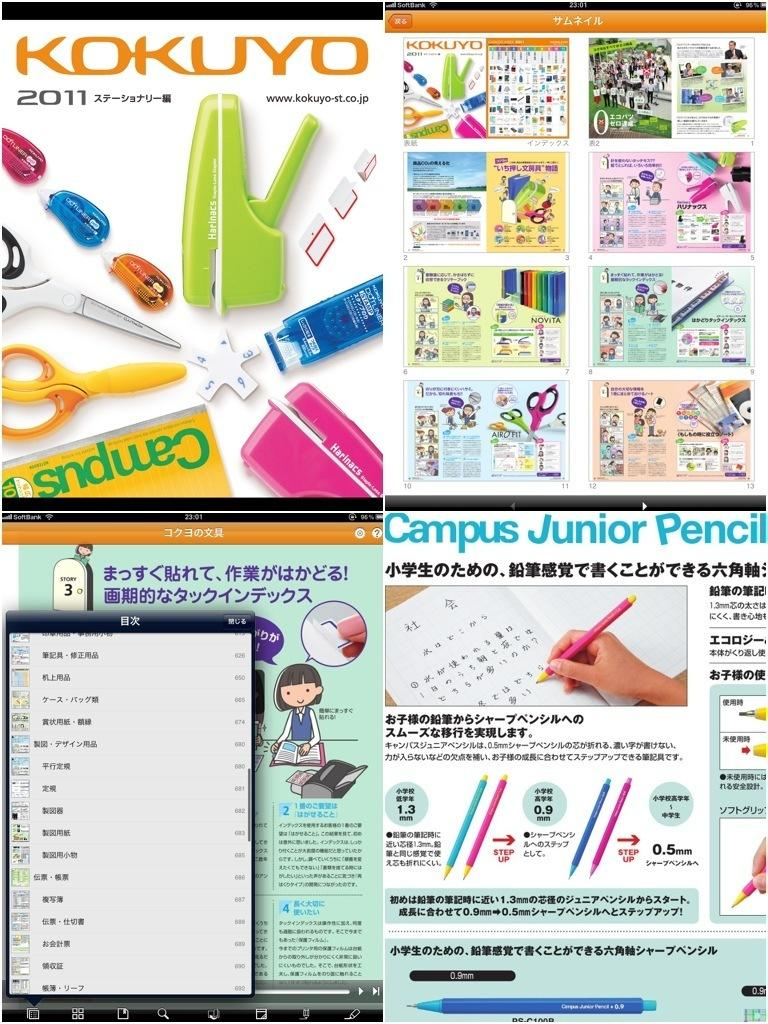What type of images are present in the collage in the image? There are collage photos in the image. What other types of images can be seen in the image? There are screenshots of electronic gadgets in the image. How many different objects are visible in the image? There are many objects in the image. Can you describe the text on the photos in the image? There is text on the photos in the image. Can you see a scarecrow smiling in the image? There is no scarecrow or smiling figure present in the image. 